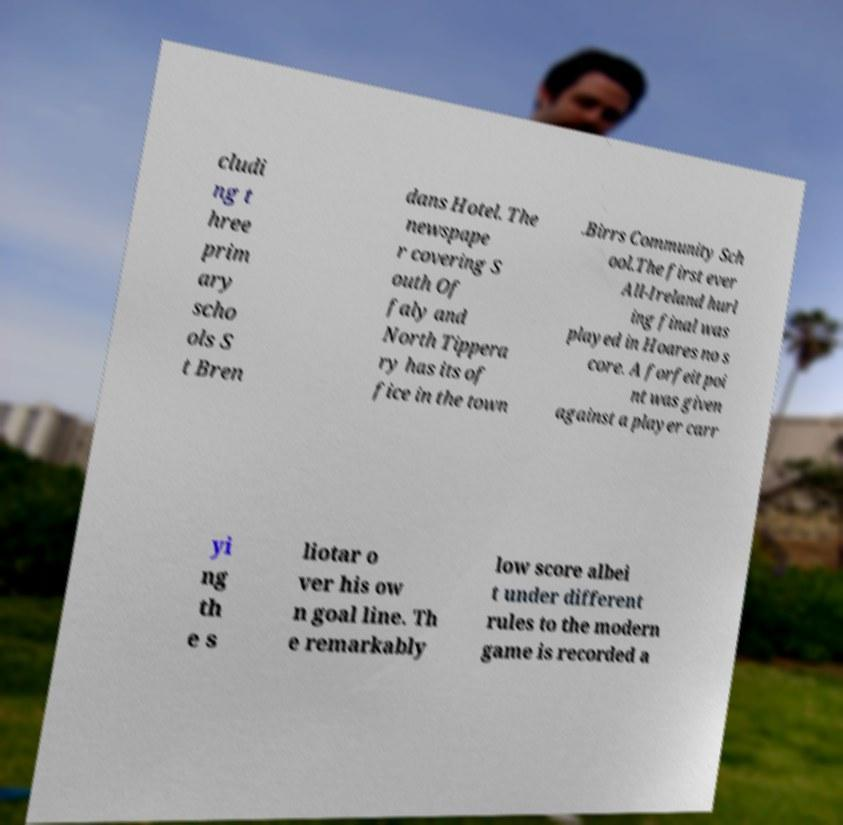Please identify and transcribe the text found in this image. cludi ng t hree prim ary scho ols S t Bren dans Hotel. The newspape r covering S outh Of faly and North Tippera ry has its of fice in the town .Birrs Community Sch ool.The first ever All-Ireland hurl ing final was played in Hoares no s core. A forfeit poi nt was given against a player carr yi ng th e s liotar o ver his ow n goal line. Th e remarkably low score albei t under different rules to the modern game is recorded a 